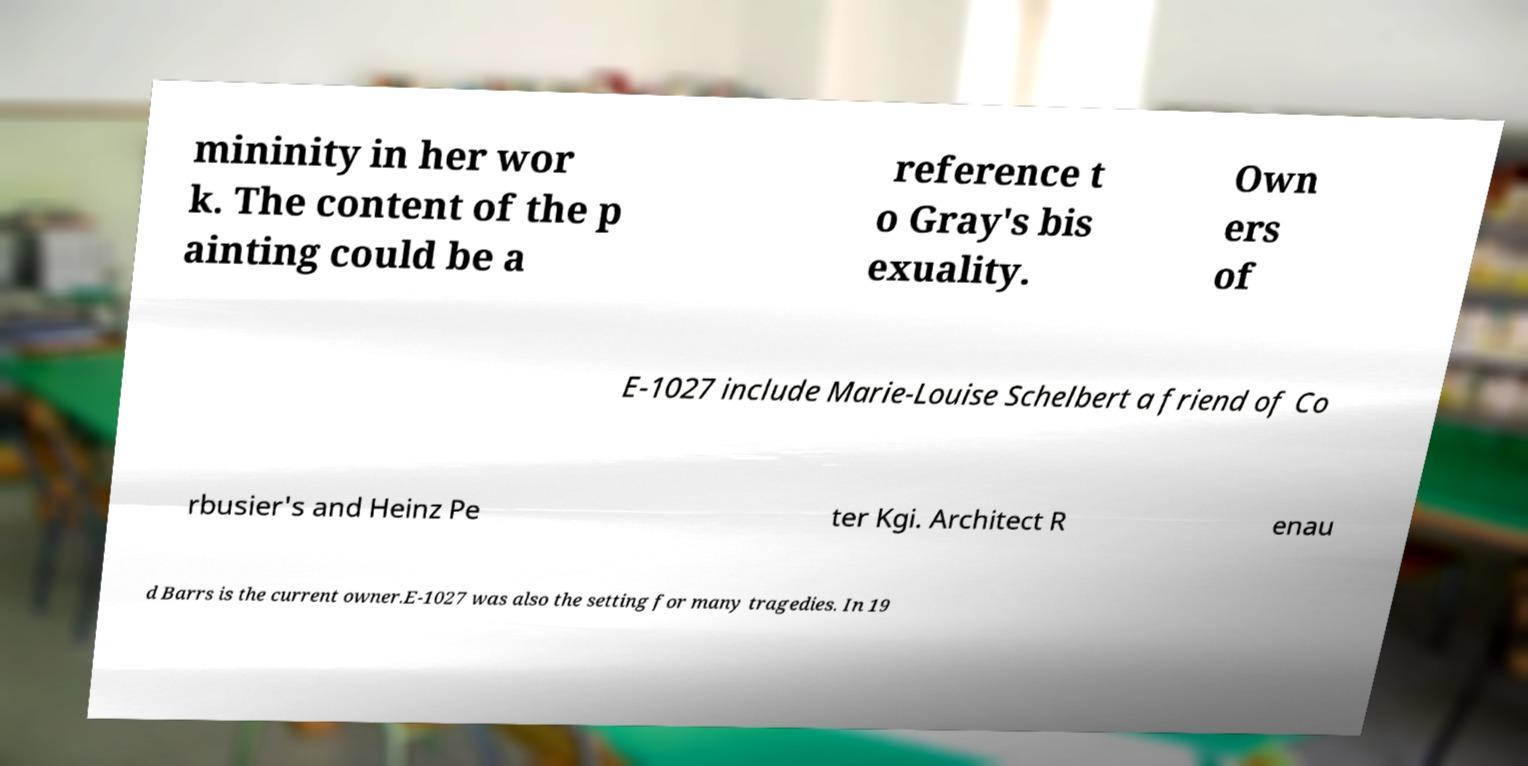For documentation purposes, I need the text within this image transcribed. Could you provide that? mininity in her wor k. The content of the p ainting could be a reference t o Gray's bis exuality. Own ers of E-1027 include Marie-Louise Schelbert a friend of Co rbusier's and Heinz Pe ter Kgi. Architect R enau d Barrs is the current owner.E-1027 was also the setting for many tragedies. In 19 